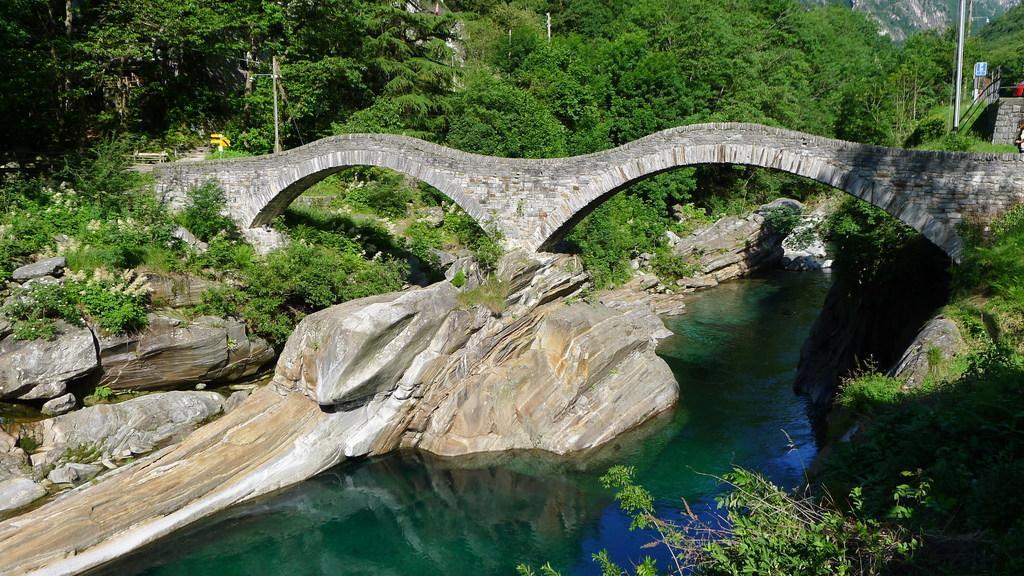Please provide a concise description of this image. In this image there is water flowing. There are rocks and plants on the water. There is a bridge across the water. In the background there are trees, poles and mountains. 